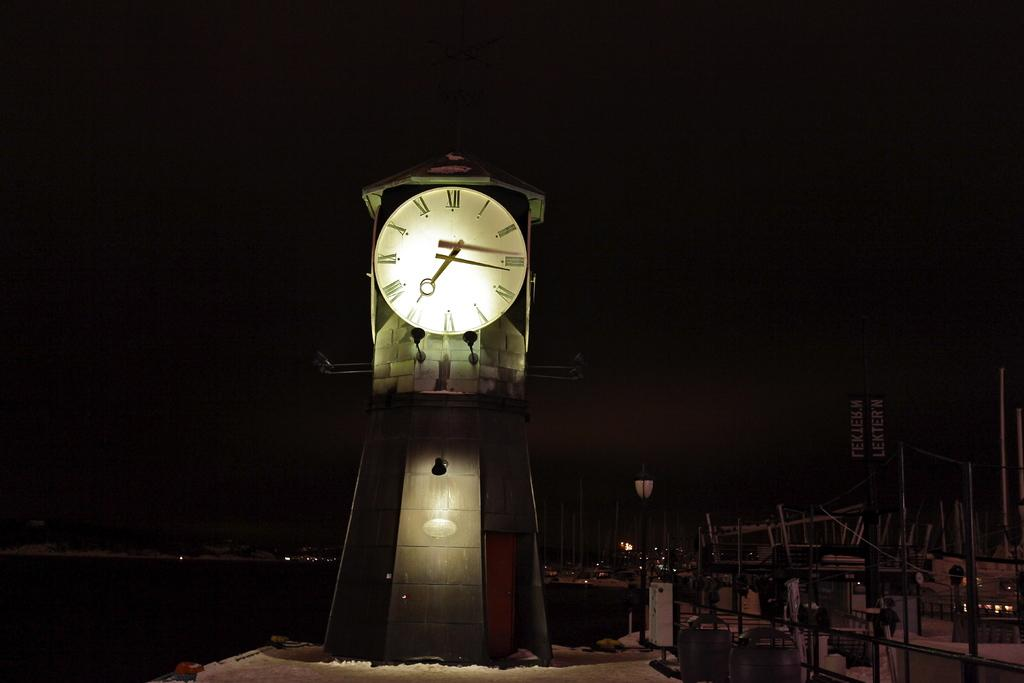<image>
Share a concise interpretation of the image provided. A large analog clock lit up at night. 